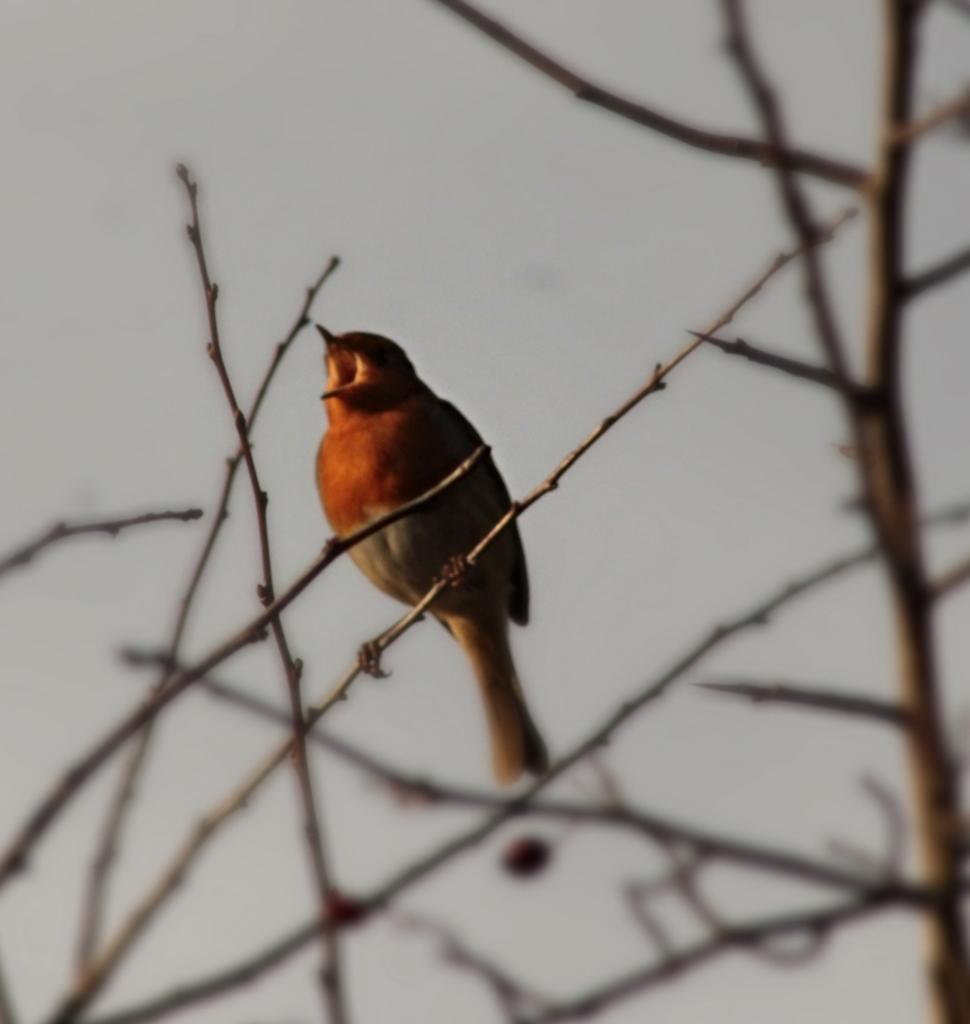What type of animal can be seen in the image? There is a bird in the image. Where is the bird located? The bird is on a branch. What is the bird sitting on? The bird is on a branch of a tree, which is on the right side of the image. What can be seen behind the bird? The sky is visible behind the bird. What channel is the bird watching in the image? There is no television or channel present in the image; it features a bird on a branch. 